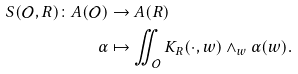Convert formula to latex. <formula><loc_0><loc_0><loc_500><loc_500>S ( \mathcal { O } , R ) \colon A ( \mathcal { O } ) & \rightarrow A ( R ) \\ \alpha & \mapsto \iint _ { \mathcal { O } } K _ { R } ( \cdot , w ) \wedge _ { w } \alpha ( w ) .</formula> 